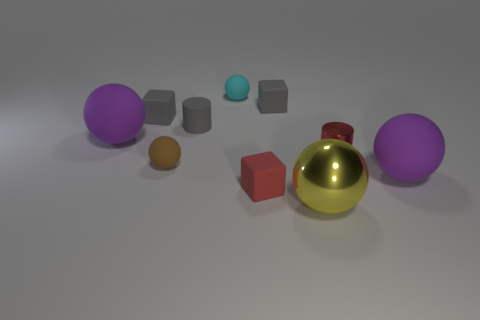Subtract all yellow blocks. Subtract all yellow spheres. How many blocks are left? 3 Subtract all cylinders. How many objects are left? 8 Add 3 big things. How many big things are left? 6 Add 7 red matte balls. How many red matte balls exist? 7 Subtract 0 cyan blocks. How many objects are left? 10 Subtract all gray metal cylinders. Subtract all matte blocks. How many objects are left? 7 